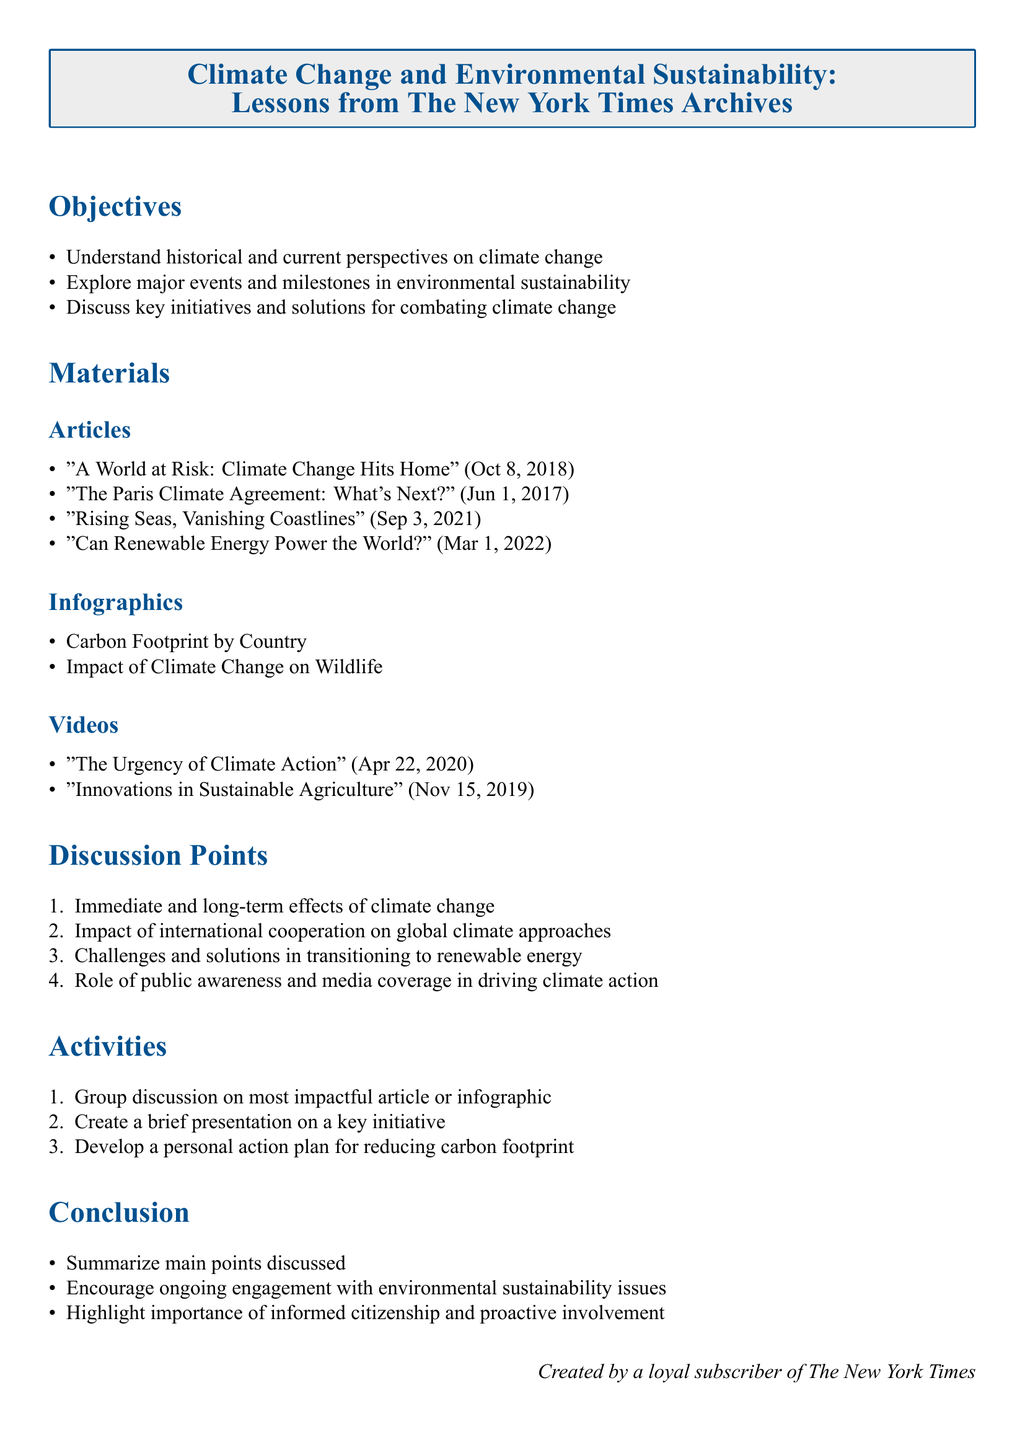What is the title of the lesson plan? The title of the lesson plan is the main heading of the document, which outlines the focus of the content.
Answer: Climate Change and Environmental Sustainability: Lessons from The New York Times Archives How many articles are listed in the materials section? The number of articles is counted from the materials section of the document.
Answer: Four What is the publication date of "A World at Risk: Climate Change Hits Home"? The publication date is provided in parentheses next to the article title in the materials section.
Answer: Oct 8, 2018 What is one of the discussion points listed in the document? A discussion point is a topic mentioned in the discussion section that encourages further conversation.
Answer: Immediate and long-term effects of climate change What type of media is "The Urgency of Climate Action"? The type of media is classified under the materials section of the document and indicates its format.
Answer: Video Which infographic is included in the materials? The infographics are listed under the materials section, providing visual information related to climate change.
Answer: Carbon Footprint by Country What is encouraged in the conclusion section? The conclusion section summarizes the lesson plan's emphases and future actions related to environmental sustainability.
Answer: Ongoing engagement with environmental sustainability issues How many activities are listed in the document? The number of activities is counted from the activities section of the lesson plan.
Answer: Three 